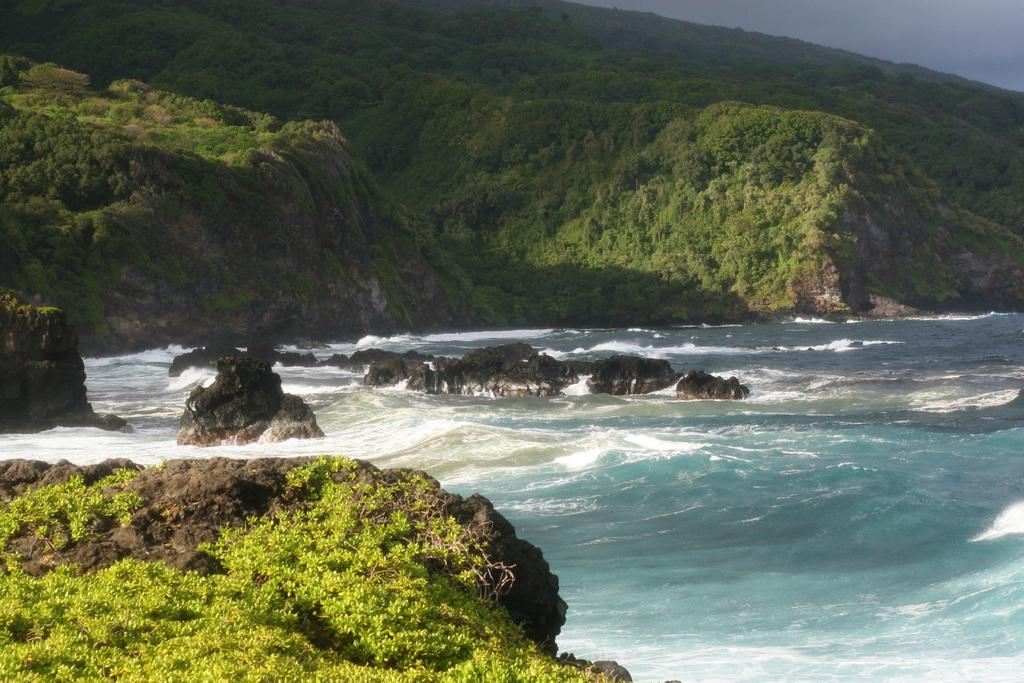Could you give a brief overview of what you see in this image? In this image there is the sky, there are mountains, there are trees on the mountains, there is a sea, there are rocks in the sea, there is a rock truncated towards the left of the image, there are plants truncated towards the bottom of the image. 